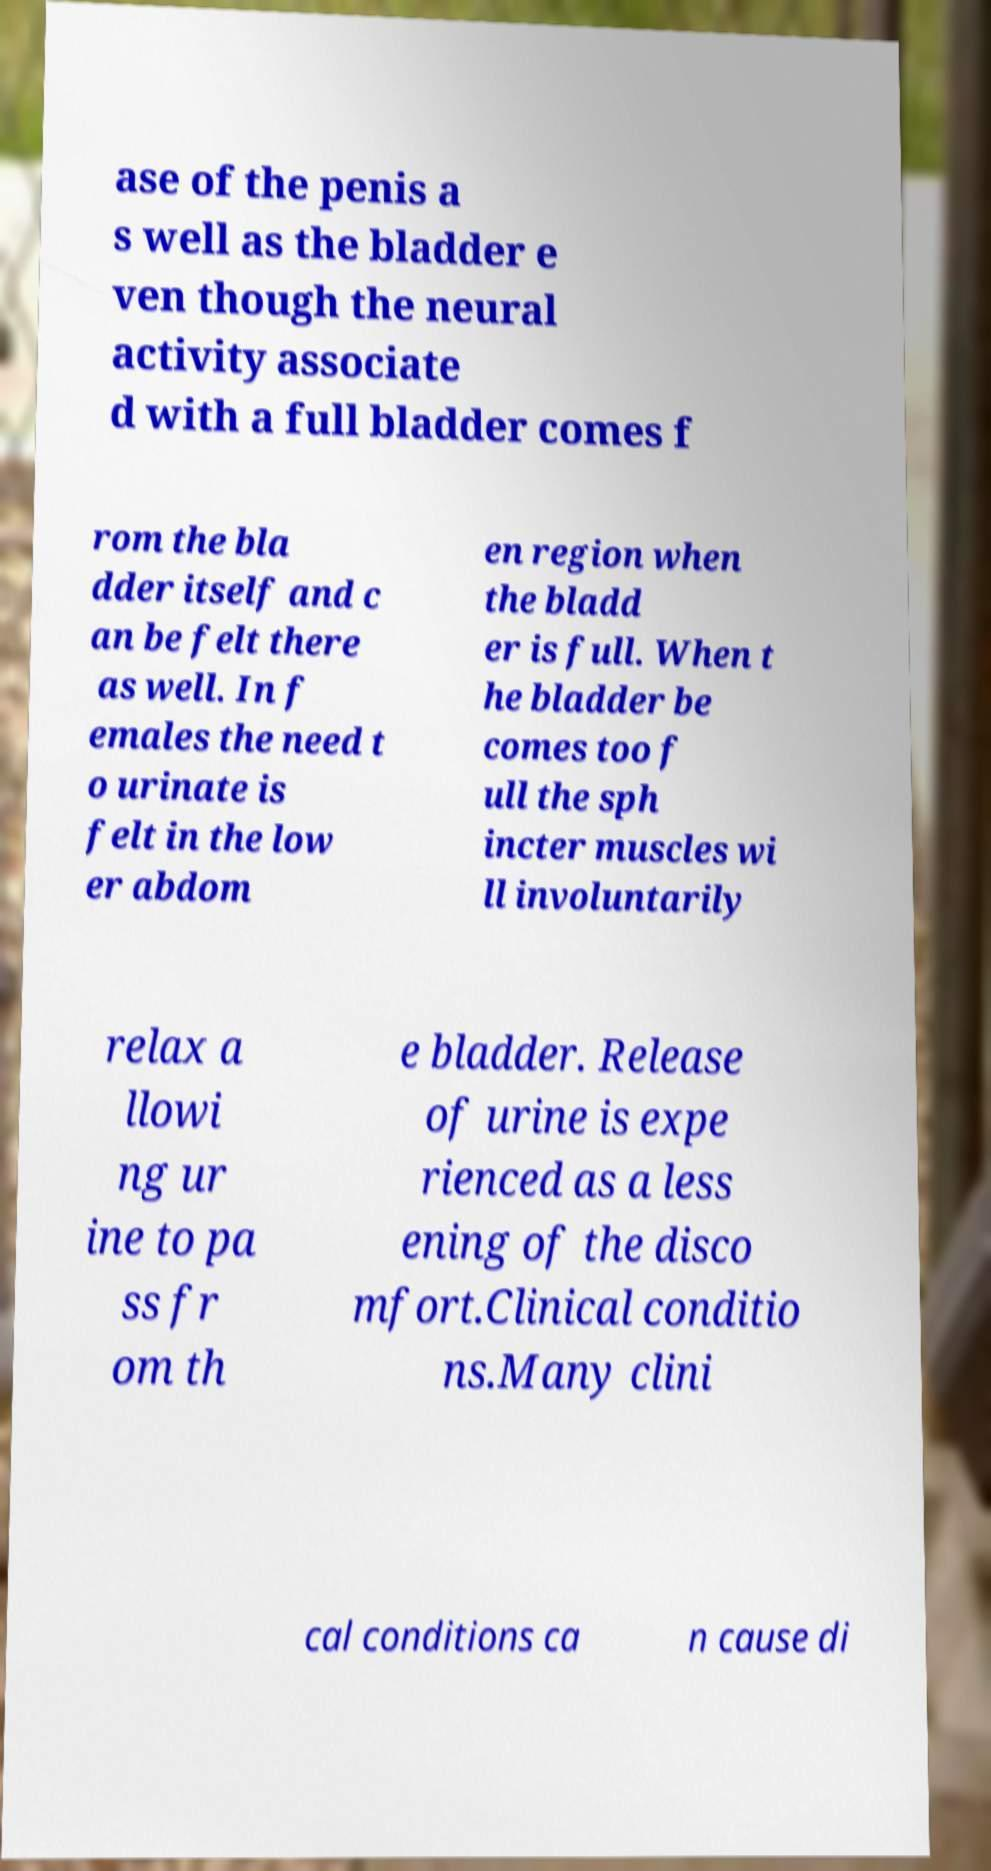Please read and relay the text visible in this image. What does it say? ase of the penis a s well as the bladder e ven though the neural activity associate d with a full bladder comes f rom the bla dder itself and c an be felt there as well. In f emales the need t o urinate is felt in the low er abdom en region when the bladd er is full. When t he bladder be comes too f ull the sph incter muscles wi ll involuntarily relax a llowi ng ur ine to pa ss fr om th e bladder. Release of urine is expe rienced as a less ening of the disco mfort.Clinical conditio ns.Many clini cal conditions ca n cause di 